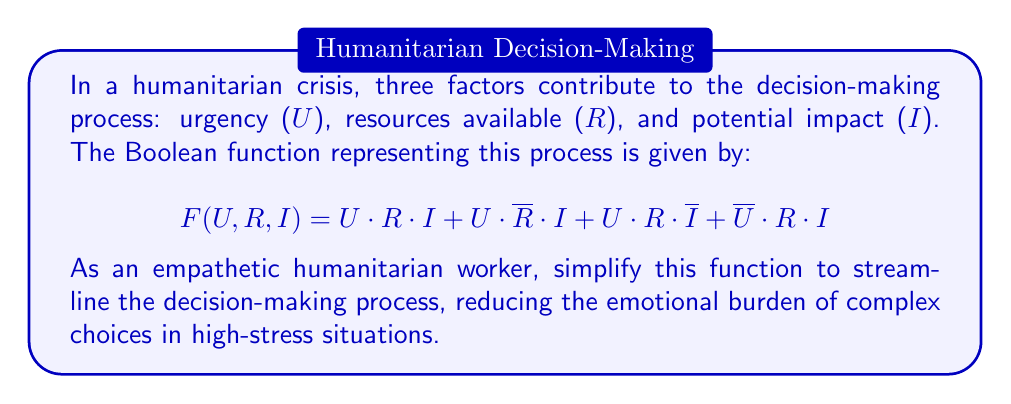Help me with this question. Let's simplify this Boolean function step-by-step:

1) First, we can apply the distributive law to factor out common terms:

   $F(U,R,I) = U \cdot I \cdot (R + \overline{R}) + U \cdot R \cdot \overline{I} + \overline{U} \cdot R \cdot I$

2) We know that $R + \overline{R} = 1$ (law of excluded middle), so:

   $F(U,R,I) = U \cdot I \cdot 1 + U \cdot R \cdot \overline{I} + \overline{U} \cdot R \cdot I$

3) Simplify:

   $F(U,R,I) = U \cdot I + U \cdot R \cdot \overline{I} + \overline{U} \cdot R \cdot I$

4) Now, we can factor out $R \cdot I$ from the last two terms:

   $F(U,R,I) = U \cdot I + R \cdot (U \cdot \overline{I} + \overline{U} \cdot I)$

5) The expression in parentheses $(U \cdot \overline{I} + \overline{U} \cdot I)$ is the exclusive OR (XOR) of U and I, which we can denote as $U \oplus I$. So:

   $F(U,R,I) = U \cdot I + R \cdot (U \oplus I)$

This simplified form reduces the complexity of the decision-making process, potentially easing the emotional toll on humanitarian workers in crisis situations.
Answer: $U \cdot I + R \cdot (U \oplus I)$ 